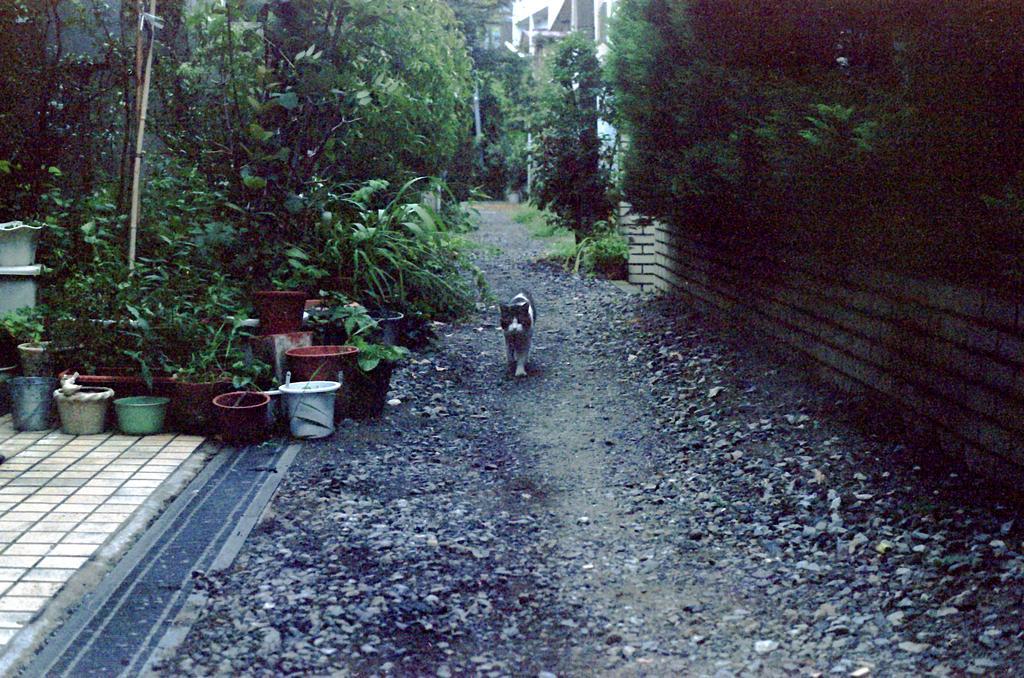Can you describe this image briefly? In the image we can see there is a cat standing on the ground and there are stones on the ground. There are plants kept in the pot and there are trees. Behind there is a building and there is a wall made up of bricks. 